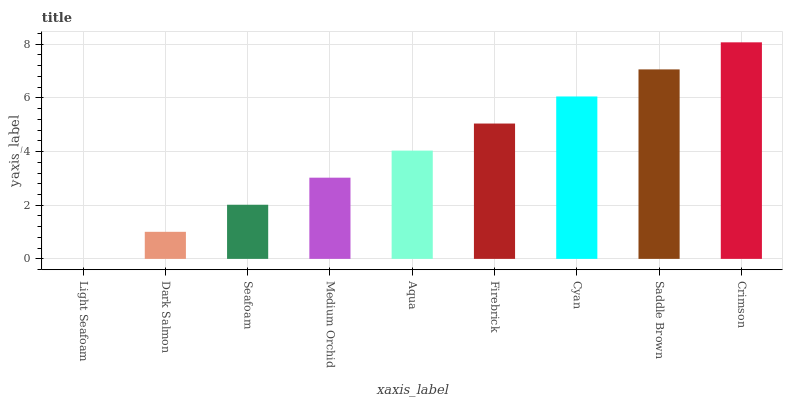Is Light Seafoam the minimum?
Answer yes or no. Yes. Is Crimson the maximum?
Answer yes or no. Yes. Is Dark Salmon the minimum?
Answer yes or no. No. Is Dark Salmon the maximum?
Answer yes or no. No. Is Dark Salmon greater than Light Seafoam?
Answer yes or no. Yes. Is Light Seafoam less than Dark Salmon?
Answer yes or no. Yes. Is Light Seafoam greater than Dark Salmon?
Answer yes or no. No. Is Dark Salmon less than Light Seafoam?
Answer yes or no. No. Is Aqua the high median?
Answer yes or no. Yes. Is Aqua the low median?
Answer yes or no. Yes. Is Cyan the high median?
Answer yes or no. No. Is Cyan the low median?
Answer yes or no. No. 